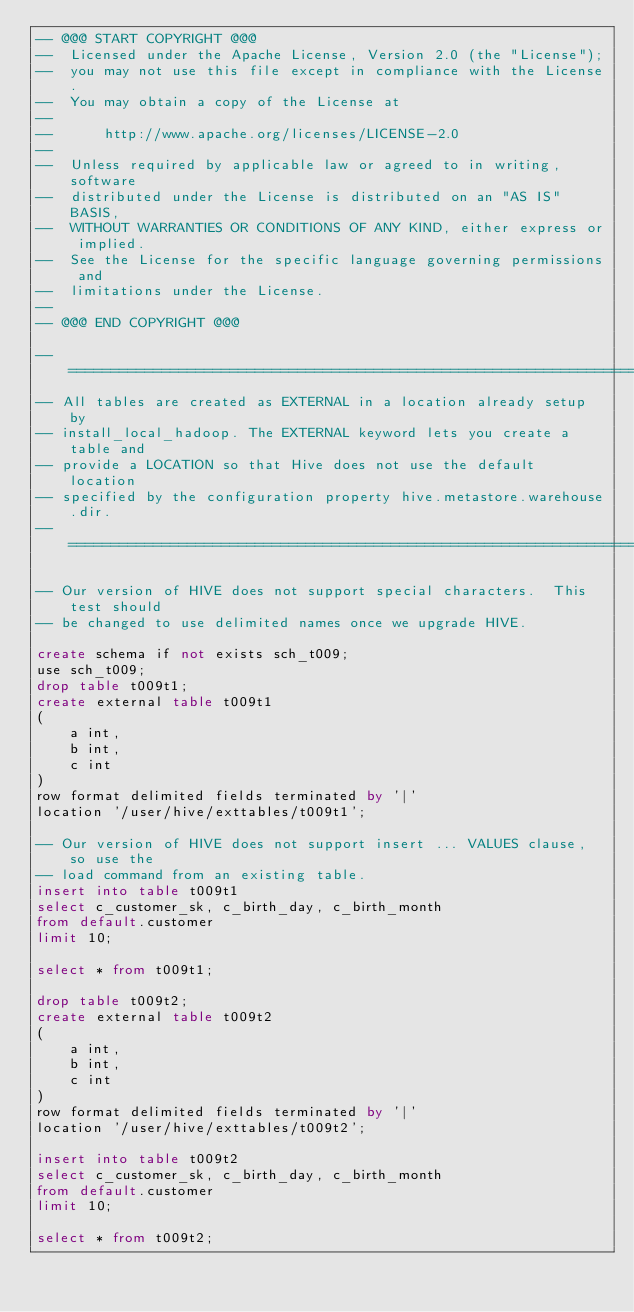<code> <loc_0><loc_0><loc_500><loc_500><_SQL_>-- @@@ START COPYRIGHT @@@
--  Licensed under the Apache License, Version 2.0 (the "License");
--  you may not use this file except in compliance with the License.
--  You may obtain a copy of the License at
--
--      http://www.apache.org/licenses/LICENSE-2.0
--
--  Unless required by applicable law or agreed to in writing, software
--  distributed under the License is distributed on an "AS IS" BASIS,
--  WITHOUT WARRANTIES OR CONDITIONS OF ANY KIND, either express or implied.
--  See the License for the specific language governing permissions and
--  limitations under the License.
--
-- @@@ END COPYRIGHT @@@

-- ============================================================================
-- All tables are created as EXTERNAL in a location already setup by 
-- install_local_hadoop. The EXTERNAL keyword lets you create a table and 
-- provide a LOCATION so that Hive does not use the default location 
-- specified by the configuration property hive.metastore.warehouse.dir.
-- ============================================================================

-- Our version of HIVE does not support special characters.  This test should 
-- be changed to use delimited names once we upgrade HIVE.

create schema if not exists sch_t009;
use sch_t009;
drop table t009t1;
create external table t009t1
(
    a int,
    b int, 
    c int
)
row format delimited fields terminated by '|'
location '/user/hive/exttables/t009t1';

-- Our version of HIVE does not support insert ... VALUES clause, so use the
-- load command from an existing table.
insert into table t009t1
select c_customer_sk, c_birth_day, c_birth_month
from default.customer
limit 10;

select * from t009t1;

drop table t009t2;
create external table t009t2
(
    a int,
    b int,
    c int
)
row format delimited fields terminated by '|'
location '/user/hive/exttables/t009t2';

insert into table t009t2
select c_customer_sk, c_birth_day, c_birth_month
from default.customer
limit 10;

select * from t009t2;


</code> 